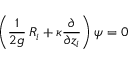Convert formula to latex. <formula><loc_0><loc_0><loc_500><loc_500>\left ( \frac { 1 } { 2 g } \, R _ { i } + \kappa \frac { \partial } { \partial z _ { i } } \right ) \psi = 0</formula> 